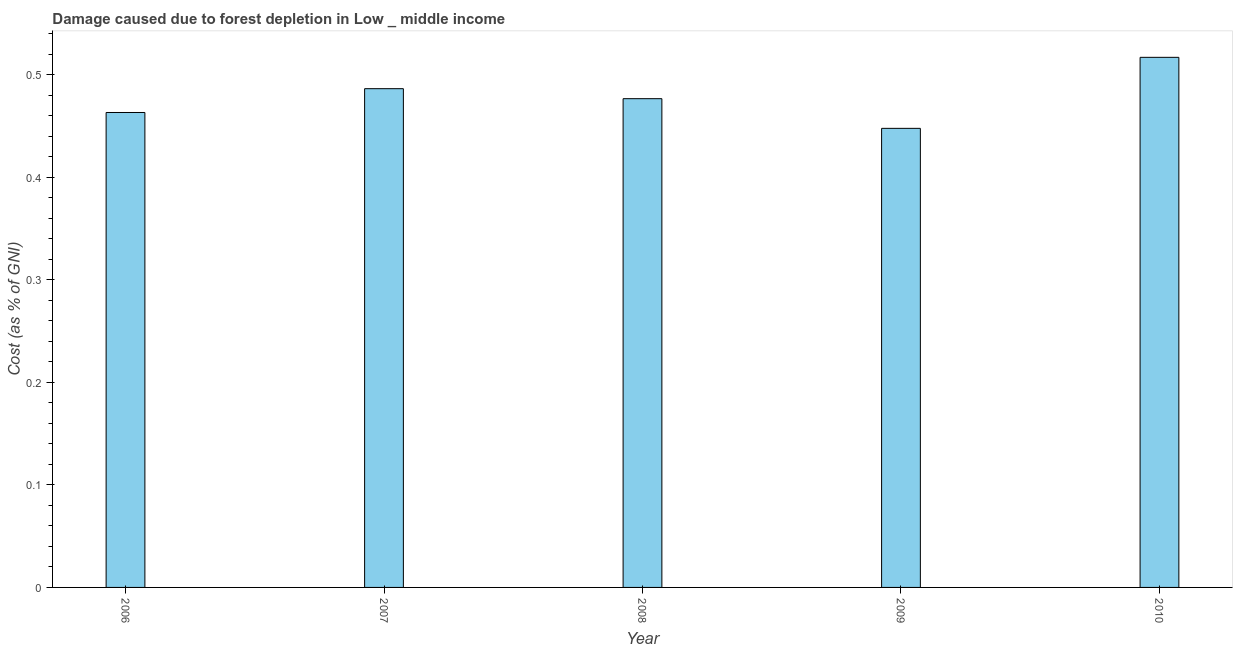What is the title of the graph?
Make the answer very short. Damage caused due to forest depletion in Low _ middle income. What is the label or title of the Y-axis?
Make the answer very short. Cost (as % of GNI). What is the damage caused due to forest depletion in 2010?
Offer a terse response. 0.52. Across all years, what is the maximum damage caused due to forest depletion?
Offer a very short reply. 0.52. Across all years, what is the minimum damage caused due to forest depletion?
Offer a very short reply. 0.45. In which year was the damage caused due to forest depletion maximum?
Offer a very short reply. 2010. In which year was the damage caused due to forest depletion minimum?
Ensure brevity in your answer.  2009. What is the sum of the damage caused due to forest depletion?
Make the answer very short. 2.39. What is the difference between the damage caused due to forest depletion in 2007 and 2010?
Your answer should be compact. -0.03. What is the average damage caused due to forest depletion per year?
Keep it short and to the point. 0.48. What is the median damage caused due to forest depletion?
Your answer should be compact. 0.48. In how many years, is the damage caused due to forest depletion greater than 0.3 %?
Make the answer very short. 5. Do a majority of the years between 2009 and 2006 (inclusive) have damage caused due to forest depletion greater than 0.52 %?
Offer a very short reply. Yes. What is the ratio of the damage caused due to forest depletion in 2006 to that in 2008?
Your answer should be very brief. 0.97. Is the damage caused due to forest depletion in 2006 less than that in 2009?
Give a very brief answer. No. Is the difference between the damage caused due to forest depletion in 2008 and 2010 greater than the difference between any two years?
Your response must be concise. No. What is the difference between the highest and the second highest damage caused due to forest depletion?
Give a very brief answer. 0.03. Is the sum of the damage caused due to forest depletion in 2007 and 2009 greater than the maximum damage caused due to forest depletion across all years?
Keep it short and to the point. Yes. What is the difference between the highest and the lowest damage caused due to forest depletion?
Your response must be concise. 0.07. How many bars are there?
Your answer should be very brief. 5. How many years are there in the graph?
Your answer should be very brief. 5. What is the difference between two consecutive major ticks on the Y-axis?
Make the answer very short. 0.1. What is the Cost (as % of GNI) in 2006?
Make the answer very short. 0.46. What is the Cost (as % of GNI) of 2007?
Provide a short and direct response. 0.49. What is the Cost (as % of GNI) in 2008?
Your response must be concise. 0.48. What is the Cost (as % of GNI) of 2009?
Give a very brief answer. 0.45. What is the Cost (as % of GNI) of 2010?
Ensure brevity in your answer.  0.52. What is the difference between the Cost (as % of GNI) in 2006 and 2007?
Offer a very short reply. -0.02. What is the difference between the Cost (as % of GNI) in 2006 and 2008?
Give a very brief answer. -0.01. What is the difference between the Cost (as % of GNI) in 2006 and 2009?
Offer a terse response. 0.02. What is the difference between the Cost (as % of GNI) in 2006 and 2010?
Offer a very short reply. -0.05. What is the difference between the Cost (as % of GNI) in 2007 and 2008?
Your answer should be compact. 0.01. What is the difference between the Cost (as % of GNI) in 2007 and 2009?
Provide a short and direct response. 0.04. What is the difference between the Cost (as % of GNI) in 2007 and 2010?
Your answer should be compact. -0.03. What is the difference between the Cost (as % of GNI) in 2008 and 2009?
Offer a terse response. 0.03. What is the difference between the Cost (as % of GNI) in 2008 and 2010?
Keep it short and to the point. -0.04. What is the difference between the Cost (as % of GNI) in 2009 and 2010?
Make the answer very short. -0.07. What is the ratio of the Cost (as % of GNI) in 2006 to that in 2007?
Offer a terse response. 0.95. What is the ratio of the Cost (as % of GNI) in 2006 to that in 2009?
Offer a very short reply. 1.03. What is the ratio of the Cost (as % of GNI) in 2006 to that in 2010?
Ensure brevity in your answer.  0.9. What is the ratio of the Cost (as % of GNI) in 2007 to that in 2009?
Provide a short and direct response. 1.09. What is the ratio of the Cost (as % of GNI) in 2007 to that in 2010?
Ensure brevity in your answer.  0.94. What is the ratio of the Cost (as % of GNI) in 2008 to that in 2009?
Ensure brevity in your answer.  1.06. What is the ratio of the Cost (as % of GNI) in 2008 to that in 2010?
Offer a very short reply. 0.92. What is the ratio of the Cost (as % of GNI) in 2009 to that in 2010?
Give a very brief answer. 0.87. 